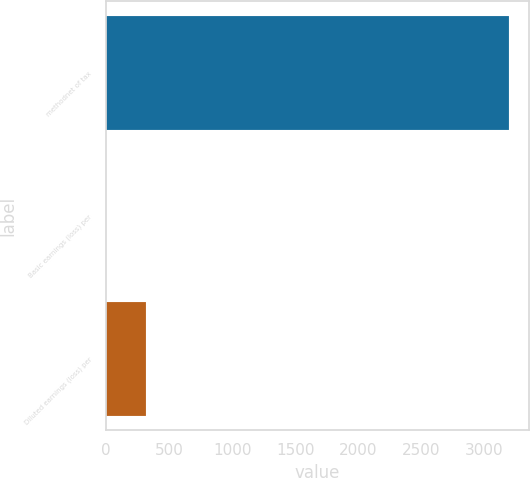<chart> <loc_0><loc_0><loc_500><loc_500><bar_chart><fcel>methodnet of tax<fcel>Basic earnings (loss) per<fcel>Diluted earnings (loss) per<nl><fcel>3194<fcel>0.17<fcel>319.55<nl></chart> 